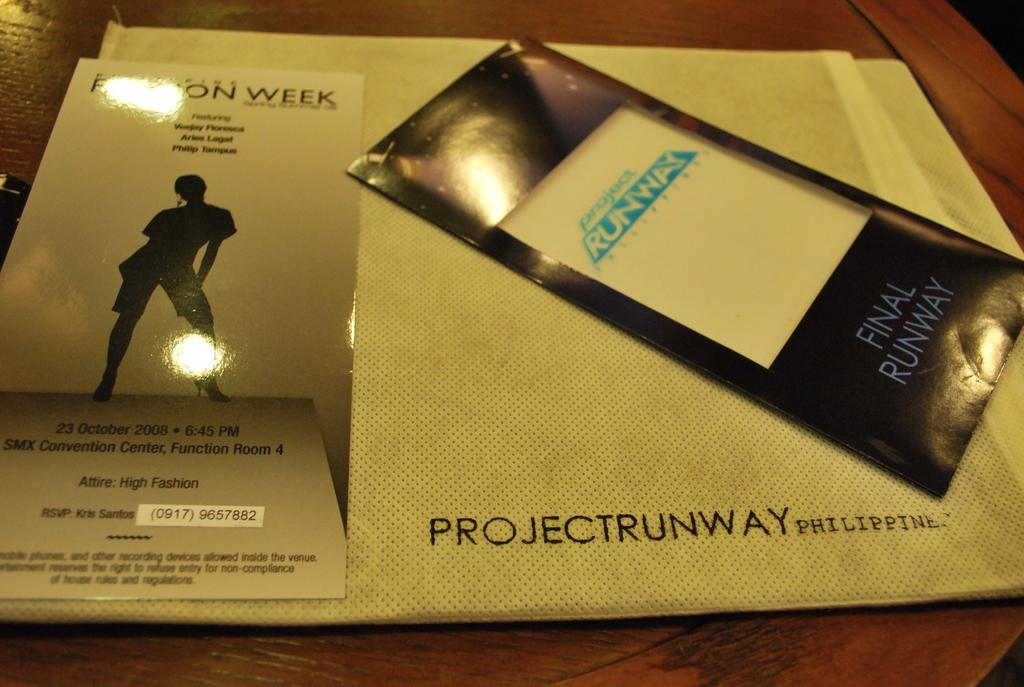What is placed on the table in the image? There is a cover and papers placed on a table in the image. What might the cover be used for? The cover might be used to protect or conceal the papers. How many items can be seen on the table in the image? There are two items on the table: a cover and papers. What type of ice can be seen melting on the tray in the image? There is no ice or tray present in the image; it features a cover and papers placed on a table. 